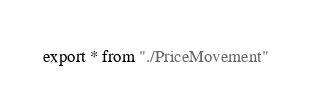Convert code to text. <code><loc_0><loc_0><loc_500><loc_500><_TypeScript_>export * from "./PriceMovement"
</code> 